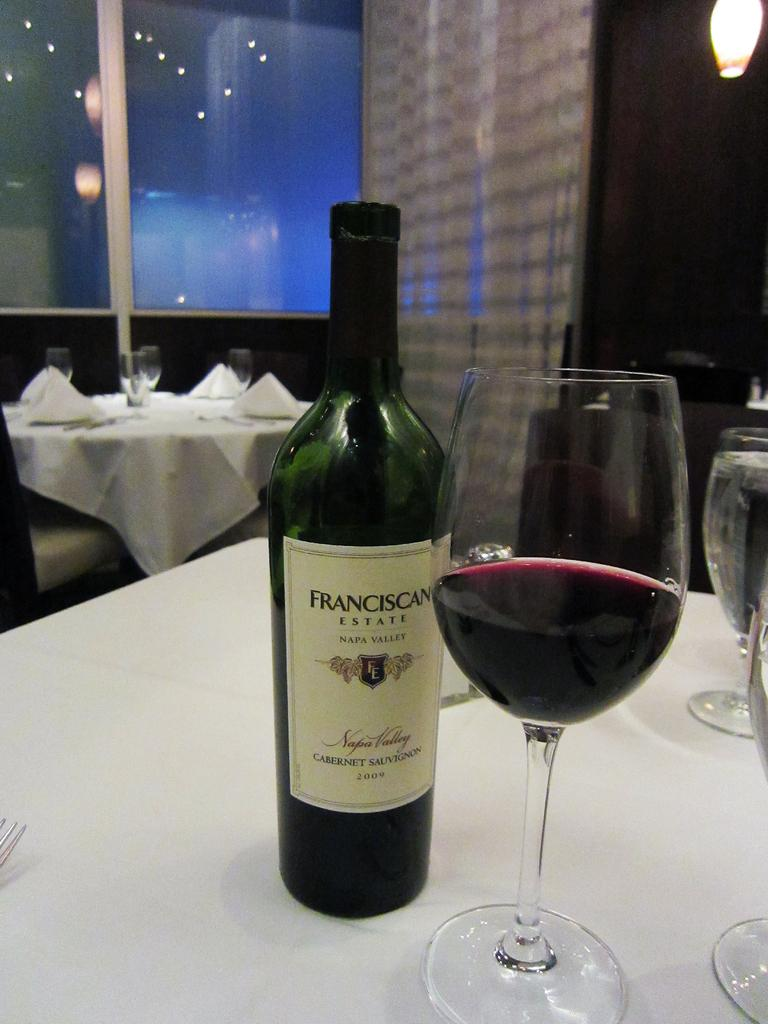Provide a one-sentence caption for the provided image. A Frankciscan wine bottle is present next to a wine glass of red wine. 